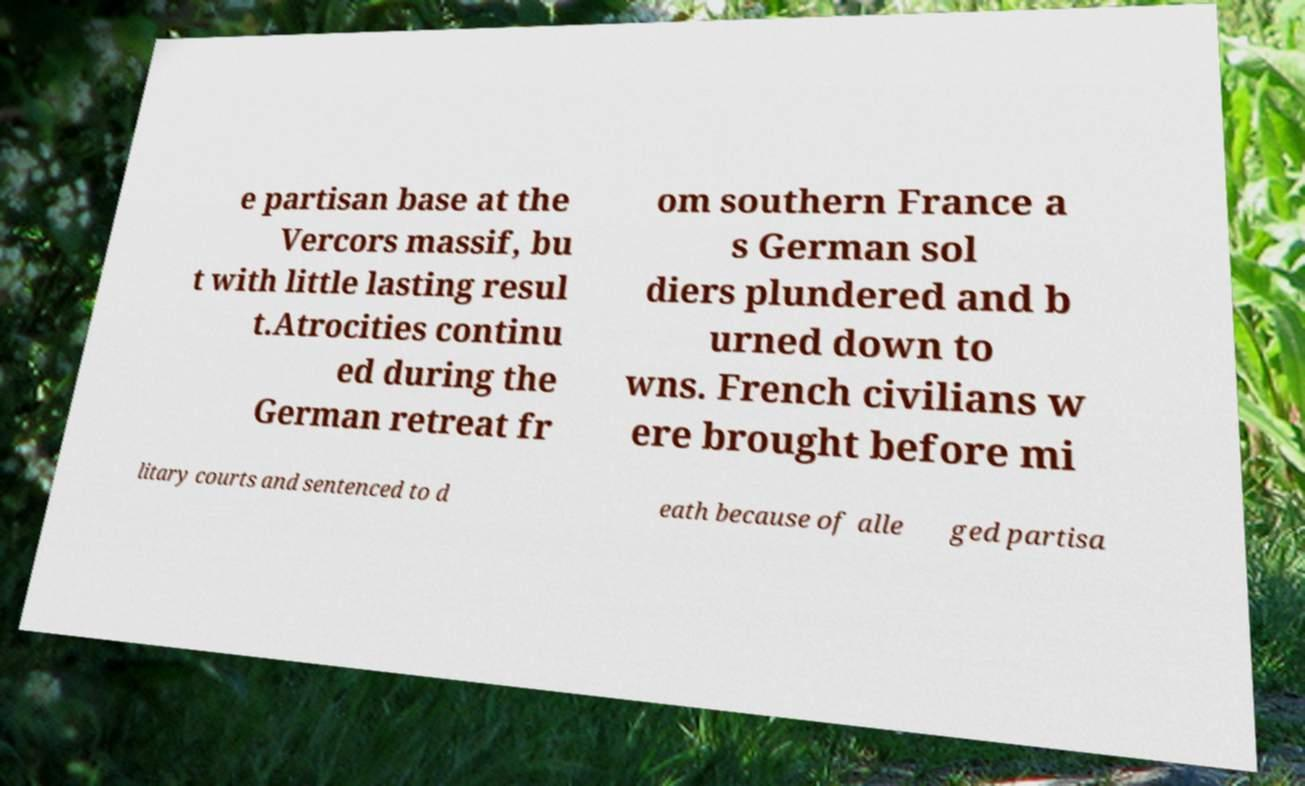For documentation purposes, I need the text within this image transcribed. Could you provide that? e partisan base at the Vercors massif, bu t with little lasting resul t.Atrocities continu ed during the German retreat fr om southern France a s German sol diers plundered and b urned down to wns. French civilians w ere brought before mi litary courts and sentenced to d eath because of alle ged partisa 